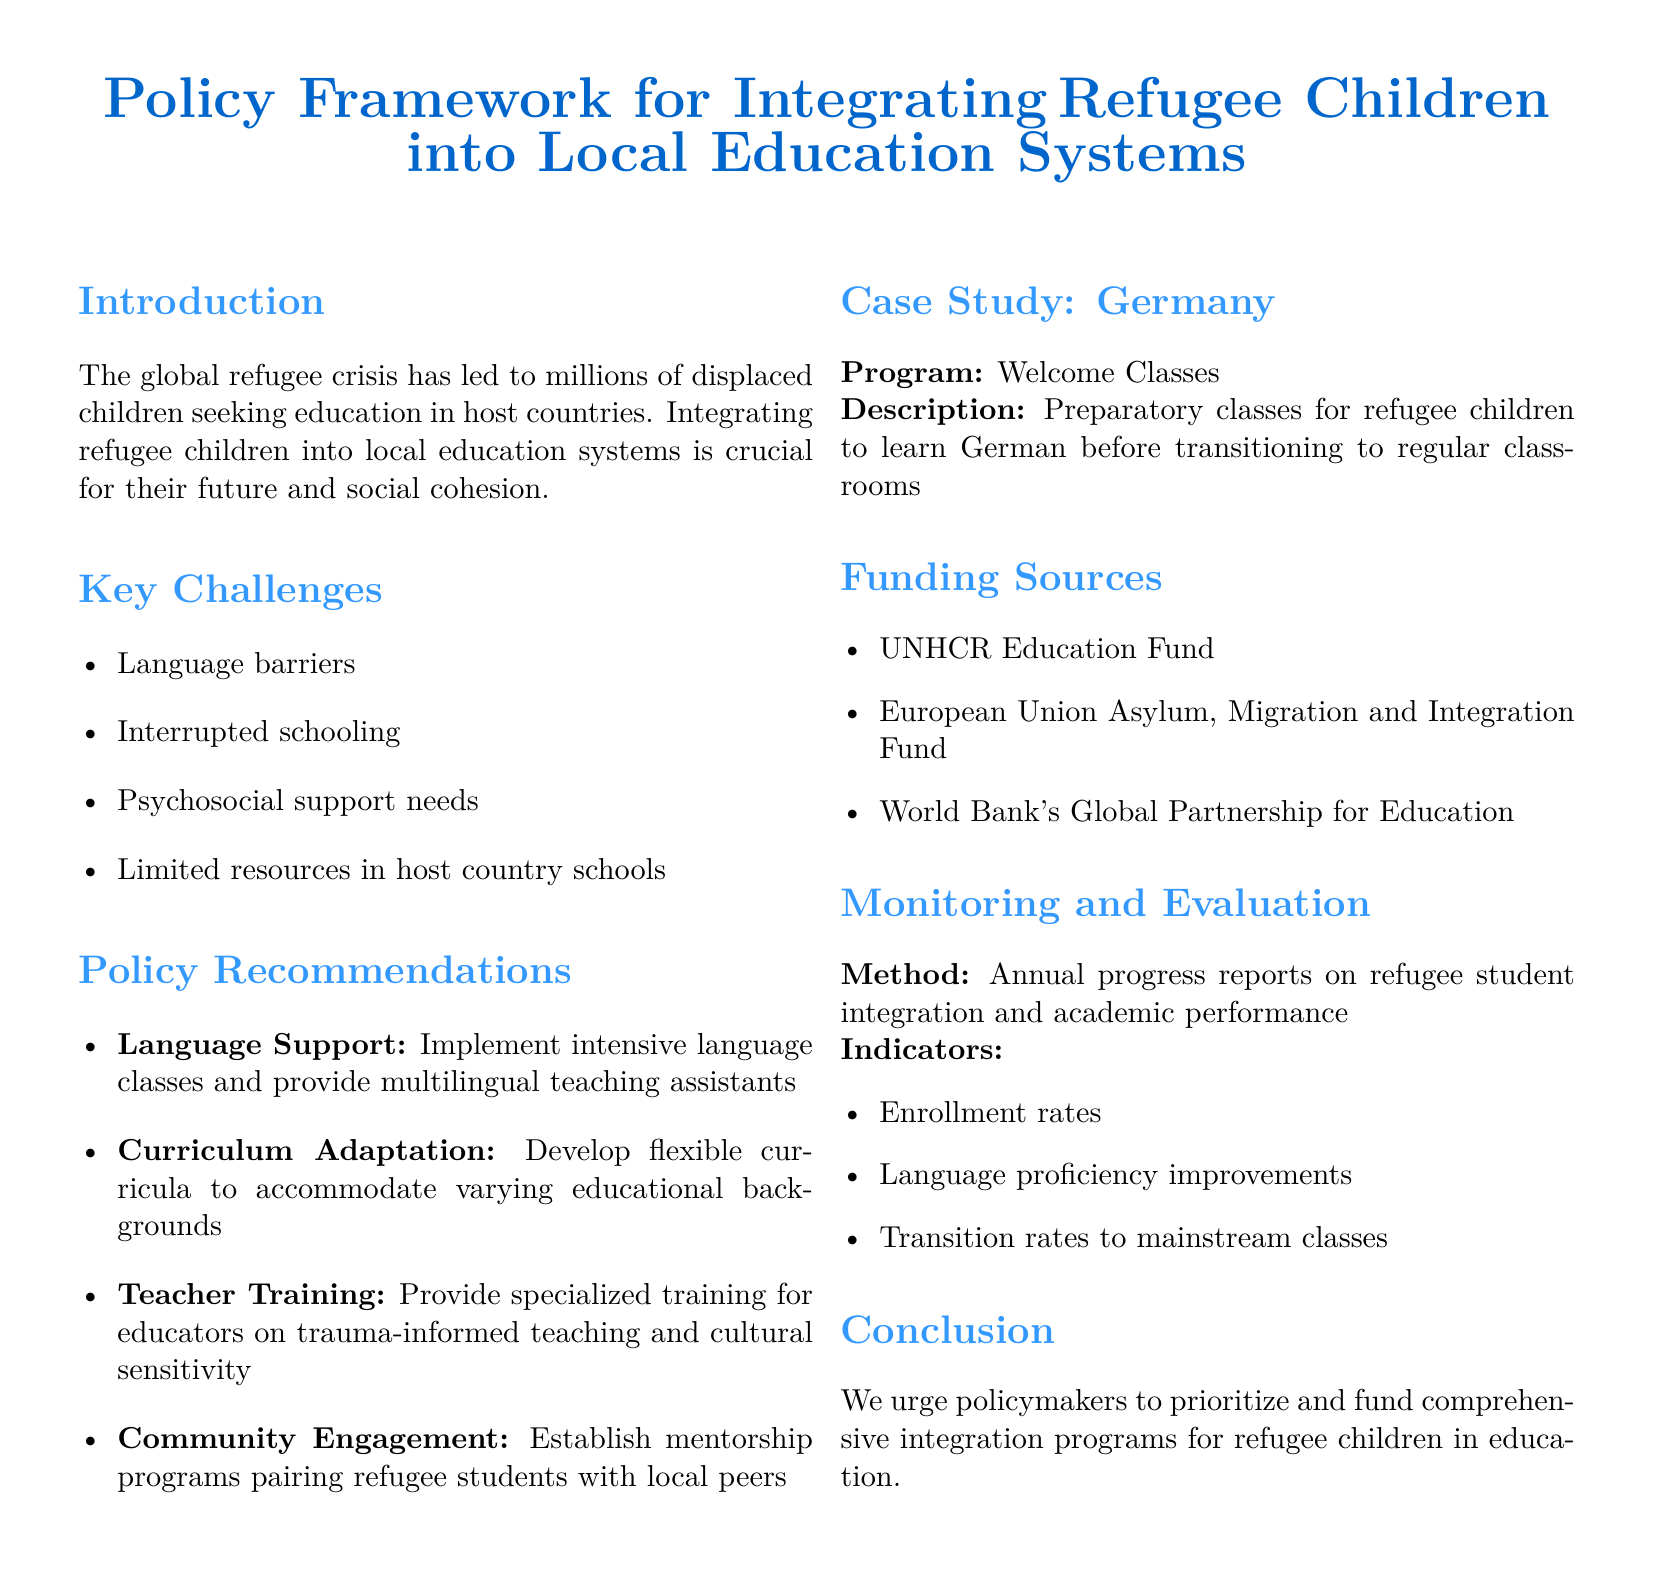What is the title of the document? The title is stated at the beginning of the document, highlighting its focus on integrating refugee children into education.
Answer: Policy Framework for Integrating Refugee Children into Local Education Systems What are the key challenges faced by refugee children in education? The document lists several key challenges that need to be addressed for effective integration.
Answer: Language barriers, Interrupted schooling, Psychosocial support needs, Limited resources in host country schools What is one of the policy recommendations regarding language support? The document specifies a recommendation related to language support aimed at improving refugee children's integration.
Answer: Implement intensive language classes and provide multilingual teaching assistants What funding source is mentioned in the document? The document includes various funding sources available to support integration programs, one of which is specified.
Answer: UNHCR Education Fund What is the method for monitoring and evaluation? The document describes a method for tracking the progress of refugee children in education based on annual assessments.
Answer: Annual progress reports on refugee student integration and academic performance What is the purpose of the Welcome Classes in Germany? The document provides a brief description of the Welcome Classes program and its intended outcome for refugee children.
Answer: Preparatory classes for refugee children to learn German before transitioning to regular classrooms What is one indicator for evaluating the progress of refugee students? The document outlines specific indicators used to measure the success of refugee children's integration into local schools.
Answer: Enrollment rates What is the focus of the case study mentioned in the document? The document highlights a specific program in Germany as a case study for successful integration efforts.
Answer: Welcome Classes 